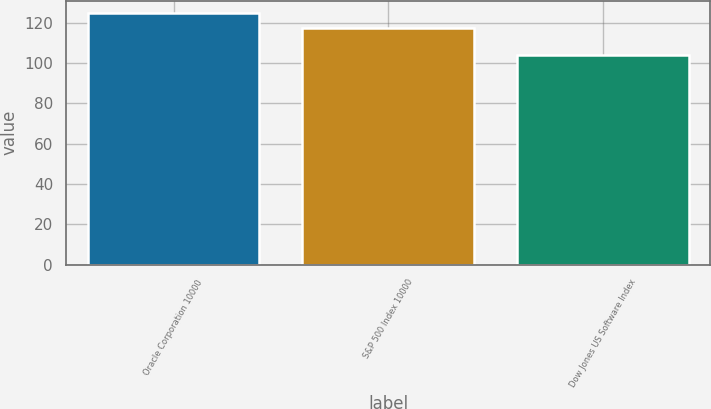Convert chart. <chart><loc_0><loc_0><loc_500><loc_500><bar_chart><fcel>Oracle Corporation 10000<fcel>S&P 500 Index 10000<fcel>Dow Jones US Software Index<nl><fcel>124.74<fcel>117.59<fcel>104.04<nl></chart> 